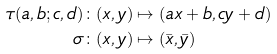<formula> <loc_0><loc_0><loc_500><loc_500>\tau ( a , b ; c , d ) & \colon ( x , y ) \mapsto ( a x + b , c y + d ) \\ \sigma & \colon ( x , y ) \mapsto ( \bar { x } , \bar { y } )</formula> 